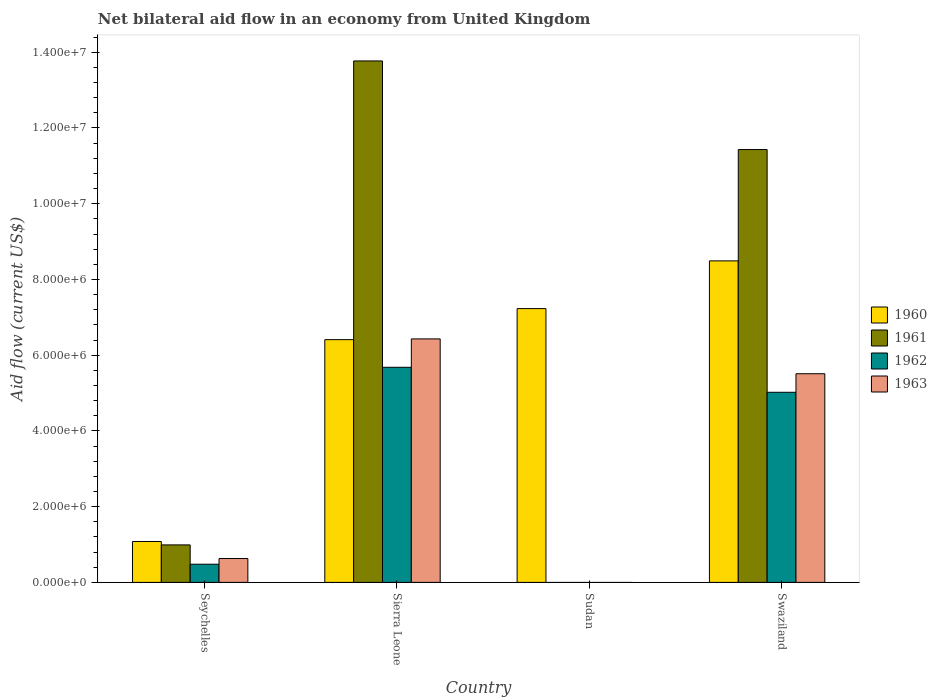How many different coloured bars are there?
Keep it short and to the point. 4. Are the number of bars on each tick of the X-axis equal?
Provide a short and direct response. No. How many bars are there on the 2nd tick from the left?
Offer a very short reply. 4. What is the label of the 1st group of bars from the left?
Provide a succinct answer. Seychelles. What is the net bilateral aid flow in 1960 in Swaziland?
Your answer should be very brief. 8.49e+06. Across all countries, what is the maximum net bilateral aid flow in 1963?
Provide a short and direct response. 6.43e+06. In which country was the net bilateral aid flow in 1961 maximum?
Keep it short and to the point. Sierra Leone. What is the total net bilateral aid flow in 1962 in the graph?
Your response must be concise. 1.12e+07. What is the difference between the net bilateral aid flow in 1963 in Seychelles and that in Sierra Leone?
Provide a short and direct response. -5.80e+06. What is the difference between the net bilateral aid flow in 1961 in Swaziland and the net bilateral aid flow in 1960 in Seychelles?
Keep it short and to the point. 1.04e+07. What is the average net bilateral aid flow in 1960 per country?
Ensure brevity in your answer.  5.80e+06. What is the difference between the net bilateral aid flow of/in 1960 and net bilateral aid flow of/in 1962 in Seychelles?
Provide a short and direct response. 6.00e+05. In how many countries, is the net bilateral aid flow in 1961 greater than 11200000 US$?
Offer a very short reply. 2. What is the ratio of the net bilateral aid flow in 1960 in Seychelles to that in Swaziland?
Provide a succinct answer. 0.13. What is the difference between the highest and the second highest net bilateral aid flow in 1961?
Provide a short and direct response. 1.28e+07. What is the difference between the highest and the lowest net bilateral aid flow in 1960?
Make the answer very short. 7.41e+06. Is the sum of the net bilateral aid flow in 1961 in Seychelles and Swaziland greater than the maximum net bilateral aid flow in 1963 across all countries?
Make the answer very short. Yes. Is it the case that in every country, the sum of the net bilateral aid flow in 1963 and net bilateral aid flow in 1961 is greater than the sum of net bilateral aid flow in 1960 and net bilateral aid flow in 1962?
Make the answer very short. No. Are all the bars in the graph horizontal?
Offer a very short reply. No. How many countries are there in the graph?
Make the answer very short. 4. What is the difference between two consecutive major ticks on the Y-axis?
Offer a very short reply. 2.00e+06. Are the values on the major ticks of Y-axis written in scientific E-notation?
Keep it short and to the point. Yes. Where does the legend appear in the graph?
Offer a very short reply. Center right. How many legend labels are there?
Offer a very short reply. 4. How are the legend labels stacked?
Make the answer very short. Vertical. What is the title of the graph?
Offer a terse response. Net bilateral aid flow in an economy from United Kingdom. Does "1960" appear as one of the legend labels in the graph?
Offer a very short reply. Yes. What is the label or title of the X-axis?
Keep it short and to the point. Country. What is the label or title of the Y-axis?
Offer a terse response. Aid flow (current US$). What is the Aid flow (current US$) of 1960 in Seychelles?
Keep it short and to the point. 1.08e+06. What is the Aid flow (current US$) in 1961 in Seychelles?
Offer a very short reply. 9.90e+05. What is the Aid flow (current US$) of 1962 in Seychelles?
Make the answer very short. 4.80e+05. What is the Aid flow (current US$) in 1963 in Seychelles?
Offer a terse response. 6.30e+05. What is the Aid flow (current US$) of 1960 in Sierra Leone?
Your answer should be compact. 6.41e+06. What is the Aid flow (current US$) of 1961 in Sierra Leone?
Keep it short and to the point. 1.38e+07. What is the Aid flow (current US$) of 1962 in Sierra Leone?
Offer a terse response. 5.68e+06. What is the Aid flow (current US$) in 1963 in Sierra Leone?
Make the answer very short. 6.43e+06. What is the Aid flow (current US$) of 1960 in Sudan?
Make the answer very short. 7.23e+06. What is the Aid flow (current US$) of 1960 in Swaziland?
Give a very brief answer. 8.49e+06. What is the Aid flow (current US$) in 1961 in Swaziland?
Provide a short and direct response. 1.14e+07. What is the Aid flow (current US$) of 1962 in Swaziland?
Your answer should be compact. 5.02e+06. What is the Aid flow (current US$) of 1963 in Swaziland?
Offer a terse response. 5.51e+06. Across all countries, what is the maximum Aid flow (current US$) of 1960?
Offer a terse response. 8.49e+06. Across all countries, what is the maximum Aid flow (current US$) of 1961?
Ensure brevity in your answer.  1.38e+07. Across all countries, what is the maximum Aid flow (current US$) in 1962?
Keep it short and to the point. 5.68e+06. Across all countries, what is the maximum Aid flow (current US$) of 1963?
Provide a succinct answer. 6.43e+06. Across all countries, what is the minimum Aid flow (current US$) of 1960?
Your answer should be very brief. 1.08e+06. Across all countries, what is the minimum Aid flow (current US$) of 1961?
Ensure brevity in your answer.  0. Across all countries, what is the minimum Aid flow (current US$) of 1962?
Provide a succinct answer. 0. Across all countries, what is the minimum Aid flow (current US$) in 1963?
Make the answer very short. 0. What is the total Aid flow (current US$) in 1960 in the graph?
Make the answer very short. 2.32e+07. What is the total Aid flow (current US$) of 1961 in the graph?
Provide a succinct answer. 2.62e+07. What is the total Aid flow (current US$) in 1962 in the graph?
Ensure brevity in your answer.  1.12e+07. What is the total Aid flow (current US$) of 1963 in the graph?
Give a very brief answer. 1.26e+07. What is the difference between the Aid flow (current US$) in 1960 in Seychelles and that in Sierra Leone?
Your response must be concise. -5.33e+06. What is the difference between the Aid flow (current US$) in 1961 in Seychelles and that in Sierra Leone?
Provide a short and direct response. -1.28e+07. What is the difference between the Aid flow (current US$) in 1962 in Seychelles and that in Sierra Leone?
Give a very brief answer. -5.20e+06. What is the difference between the Aid flow (current US$) in 1963 in Seychelles and that in Sierra Leone?
Your answer should be compact. -5.80e+06. What is the difference between the Aid flow (current US$) of 1960 in Seychelles and that in Sudan?
Provide a succinct answer. -6.15e+06. What is the difference between the Aid flow (current US$) of 1960 in Seychelles and that in Swaziland?
Provide a succinct answer. -7.41e+06. What is the difference between the Aid flow (current US$) in 1961 in Seychelles and that in Swaziland?
Your response must be concise. -1.04e+07. What is the difference between the Aid flow (current US$) of 1962 in Seychelles and that in Swaziland?
Your answer should be compact. -4.54e+06. What is the difference between the Aid flow (current US$) in 1963 in Seychelles and that in Swaziland?
Provide a succinct answer. -4.88e+06. What is the difference between the Aid flow (current US$) in 1960 in Sierra Leone and that in Sudan?
Offer a very short reply. -8.20e+05. What is the difference between the Aid flow (current US$) of 1960 in Sierra Leone and that in Swaziland?
Keep it short and to the point. -2.08e+06. What is the difference between the Aid flow (current US$) of 1961 in Sierra Leone and that in Swaziland?
Your answer should be very brief. 2.34e+06. What is the difference between the Aid flow (current US$) in 1962 in Sierra Leone and that in Swaziland?
Your answer should be compact. 6.60e+05. What is the difference between the Aid flow (current US$) in 1963 in Sierra Leone and that in Swaziland?
Offer a very short reply. 9.20e+05. What is the difference between the Aid flow (current US$) in 1960 in Sudan and that in Swaziland?
Ensure brevity in your answer.  -1.26e+06. What is the difference between the Aid flow (current US$) in 1960 in Seychelles and the Aid flow (current US$) in 1961 in Sierra Leone?
Offer a terse response. -1.27e+07. What is the difference between the Aid flow (current US$) in 1960 in Seychelles and the Aid flow (current US$) in 1962 in Sierra Leone?
Keep it short and to the point. -4.60e+06. What is the difference between the Aid flow (current US$) in 1960 in Seychelles and the Aid flow (current US$) in 1963 in Sierra Leone?
Your answer should be very brief. -5.35e+06. What is the difference between the Aid flow (current US$) in 1961 in Seychelles and the Aid flow (current US$) in 1962 in Sierra Leone?
Your answer should be compact. -4.69e+06. What is the difference between the Aid flow (current US$) in 1961 in Seychelles and the Aid flow (current US$) in 1963 in Sierra Leone?
Provide a short and direct response. -5.44e+06. What is the difference between the Aid flow (current US$) of 1962 in Seychelles and the Aid flow (current US$) of 1963 in Sierra Leone?
Provide a succinct answer. -5.95e+06. What is the difference between the Aid flow (current US$) of 1960 in Seychelles and the Aid flow (current US$) of 1961 in Swaziland?
Your answer should be very brief. -1.04e+07. What is the difference between the Aid flow (current US$) of 1960 in Seychelles and the Aid flow (current US$) of 1962 in Swaziland?
Give a very brief answer. -3.94e+06. What is the difference between the Aid flow (current US$) in 1960 in Seychelles and the Aid flow (current US$) in 1963 in Swaziland?
Offer a terse response. -4.43e+06. What is the difference between the Aid flow (current US$) of 1961 in Seychelles and the Aid flow (current US$) of 1962 in Swaziland?
Provide a short and direct response. -4.03e+06. What is the difference between the Aid flow (current US$) of 1961 in Seychelles and the Aid flow (current US$) of 1963 in Swaziland?
Provide a succinct answer. -4.52e+06. What is the difference between the Aid flow (current US$) in 1962 in Seychelles and the Aid flow (current US$) in 1963 in Swaziland?
Make the answer very short. -5.03e+06. What is the difference between the Aid flow (current US$) of 1960 in Sierra Leone and the Aid flow (current US$) of 1961 in Swaziland?
Your answer should be compact. -5.02e+06. What is the difference between the Aid flow (current US$) of 1960 in Sierra Leone and the Aid flow (current US$) of 1962 in Swaziland?
Your answer should be compact. 1.39e+06. What is the difference between the Aid flow (current US$) of 1961 in Sierra Leone and the Aid flow (current US$) of 1962 in Swaziland?
Your answer should be very brief. 8.75e+06. What is the difference between the Aid flow (current US$) in 1961 in Sierra Leone and the Aid flow (current US$) in 1963 in Swaziland?
Make the answer very short. 8.26e+06. What is the difference between the Aid flow (current US$) of 1960 in Sudan and the Aid flow (current US$) of 1961 in Swaziland?
Provide a succinct answer. -4.20e+06. What is the difference between the Aid flow (current US$) in 1960 in Sudan and the Aid flow (current US$) in 1962 in Swaziland?
Your answer should be very brief. 2.21e+06. What is the difference between the Aid flow (current US$) in 1960 in Sudan and the Aid flow (current US$) in 1963 in Swaziland?
Offer a terse response. 1.72e+06. What is the average Aid flow (current US$) in 1960 per country?
Provide a short and direct response. 5.80e+06. What is the average Aid flow (current US$) in 1961 per country?
Offer a very short reply. 6.55e+06. What is the average Aid flow (current US$) of 1962 per country?
Provide a short and direct response. 2.80e+06. What is the average Aid flow (current US$) of 1963 per country?
Offer a terse response. 3.14e+06. What is the difference between the Aid flow (current US$) in 1960 and Aid flow (current US$) in 1961 in Seychelles?
Make the answer very short. 9.00e+04. What is the difference between the Aid flow (current US$) of 1960 and Aid flow (current US$) of 1963 in Seychelles?
Your answer should be very brief. 4.50e+05. What is the difference between the Aid flow (current US$) in 1961 and Aid flow (current US$) in 1962 in Seychelles?
Give a very brief answer. 5.10e+05. What is the difference between the Aid flow (current US$) of 1961 and Aid flow (current US$) of 1963 in Seychelles?
Ensure brevity in your answer.  3.60e+05. What is the difference between the Aid flow (current US$) in 1960 and Aid flow (current US$) in 1961 in Sierra Leone?
Provide a succinct answer. -7.36e+06. What is the difference between the Aid flow (current US$) in 1960 and Aid flow (current US$) in 1962 in Sierra Leone?
Offer a very short reply. 7.30e+05. What is the difference between the Aid flow (current US$) in 1960 and Aid flow (current US$) in 1963 in Sierra Leone?
Give a very brief answer. -2.00e+04. What is the difference between the Aid flow (current US$) of 1961 and Aid flow (current US$) of 1962 in Sierra Leone?
Provide a short and direct response. 8.09e+06. What is the difference between the Aid flow (current US$) of 1961 and Aid flow (current US$) of 1963 in Sierra Leone?
Keep it short and to the point. 7.34e+06. What is the difference between the Aid flow (current US$) of 1962 and Aid flow (current US$) of 1963 in Sierra Leone?
Offer a terse response. -7.50e+05. What is the difference between the Aid flow (current US$) of 1960 and Aid flow (current US$) of 1961 in Swaziland?
Your response must be concise. -2.94e+06. What is the difference between the Aid flow (current US$) in 1960 and Aid flow (current US$) in 1962 in Swaziland?
Make the answer very short. 3.47e+06. What is the difference between the Aid flow (current US$) of 1960 and Aid flow (current US$) of 1963 in Swaziland?
Make the answer very short. 2.98e+06. What is the difference between the Aid flow (current US$) in 1961 and Aid flow (current US$) in 1962 in Swaziland?
Keep it short and to the point. 6.41e+06. What is the difference between the Aid flow (current US$) of 1961 and Aid flow (current US$) of 1963 in Swaziland?
Make the answer very short. 5.92e+06. What is the difference between the Aid flow (current US$) in 1962 and Aid flow (current US$) in 1963 in Swaziland?
Keep it short and to the point. -4.90e+05. What is the ratio of the Aid flow (current US$) of 1960 in Seychelles to that in Sierra Leone?
Ensure brevity in your answer.  0.17. What is the ratio of the Aid flow (current US$) in 1961 in Seychelles to that in Sierra Leone?
Offer a terse response. 0.07. What is the ratio of the Aid flow (current US$) in 1962 in Seychelles to that in Sierra Leone?
Your answer should be compact. 0.08. What is the ratio of the Aid flow (current US$) of 1963 in Seychelles to that in Sierra Leone?
Offer a terse response. 0.1. What is the ratio of the Aid flow (current US$) in 1960 in Seychelles to that in Sudan?
Ensure brevity in your answer.  0.15. What is the ratio of the Aid flow (current US$) of 1960 in Seychelles to that in Swaziland?
Offer a very short reply. 0.13. What is the ratio of the Aid flow (current US$) of 1961 in Seychelles to that in Swaziland?
Offer a very short reply. 0.09. What is the ratio of the Aid flow (current US$) in 1962 in Seychelles to that in Swaziland?
Provide a short and direct response. 0.1. What is the ratio of the Aid flow (current US$) in 1963 in Seychelles to that in Swaziland?
Your answer should be compact. 0.11. What is the ratio of the Aid flow (current US$) of 1960 in Sierra Leone to that in Sudan?
Make the answer very short. 0.89. What is the ratio of the Aid flow (current US$) of 1960 in Sierra Leone to that in Swaziland?
Ensure brevity in your answer.  0.76. What is the ratio of the Aid flow (current US$) in 1961 in Sierra Leone to that in Swaziland?
Your answer should be compact. 1.2. What is the ratio of the Aid flow (current US$) of 1962 in Sierra Leone to that in Swaziland?
Give a very brief answer. 1.13. What is the ratio of the Aid flow (current US$) in 1963 in Sierra Leone to that in Swaziland?
Provide a short and direct response. 1.17. What is the ratio of the Aid flow (current US$) of 1960 in Sudan to that in Swaziland?
Make the answer very short. 0.85. What is the difference between the highest and the second highest Aid flow (current US$) of 1960?
Keep it short and to the point. 1.26e+06. What is the difference between the highest and the second highest Aid flow (current US$) of 1961?
Keep it short and to the point. 2.34e+06. What is the difference between the highest and the second highest Aid flow (current US$) in 1962?
Your answer should be very brief. 6.60e+05. What is the difference between the highest and the second highest Aid flow (current US$) in 1963?
Provide a short and direct response. 9.20e+05. What is the difference between the highest and the lowest Aid flow (current US$) in 1960?
Provide a succinct answer. 7.41e+06. What is the difference between the highest and the lowest Aid flow (current US$) of 1961?
Provide a succinct answer. 1.38e+07. What is the difference between the highest and the lowest Aid flow (current US$) in 1962?
Ensure brevity in your answer.  5.68e+06. What is the difference between the highest and the lowest Aid flow (current US$) of 1963?
Offer a terse response. 6.43e+06. 